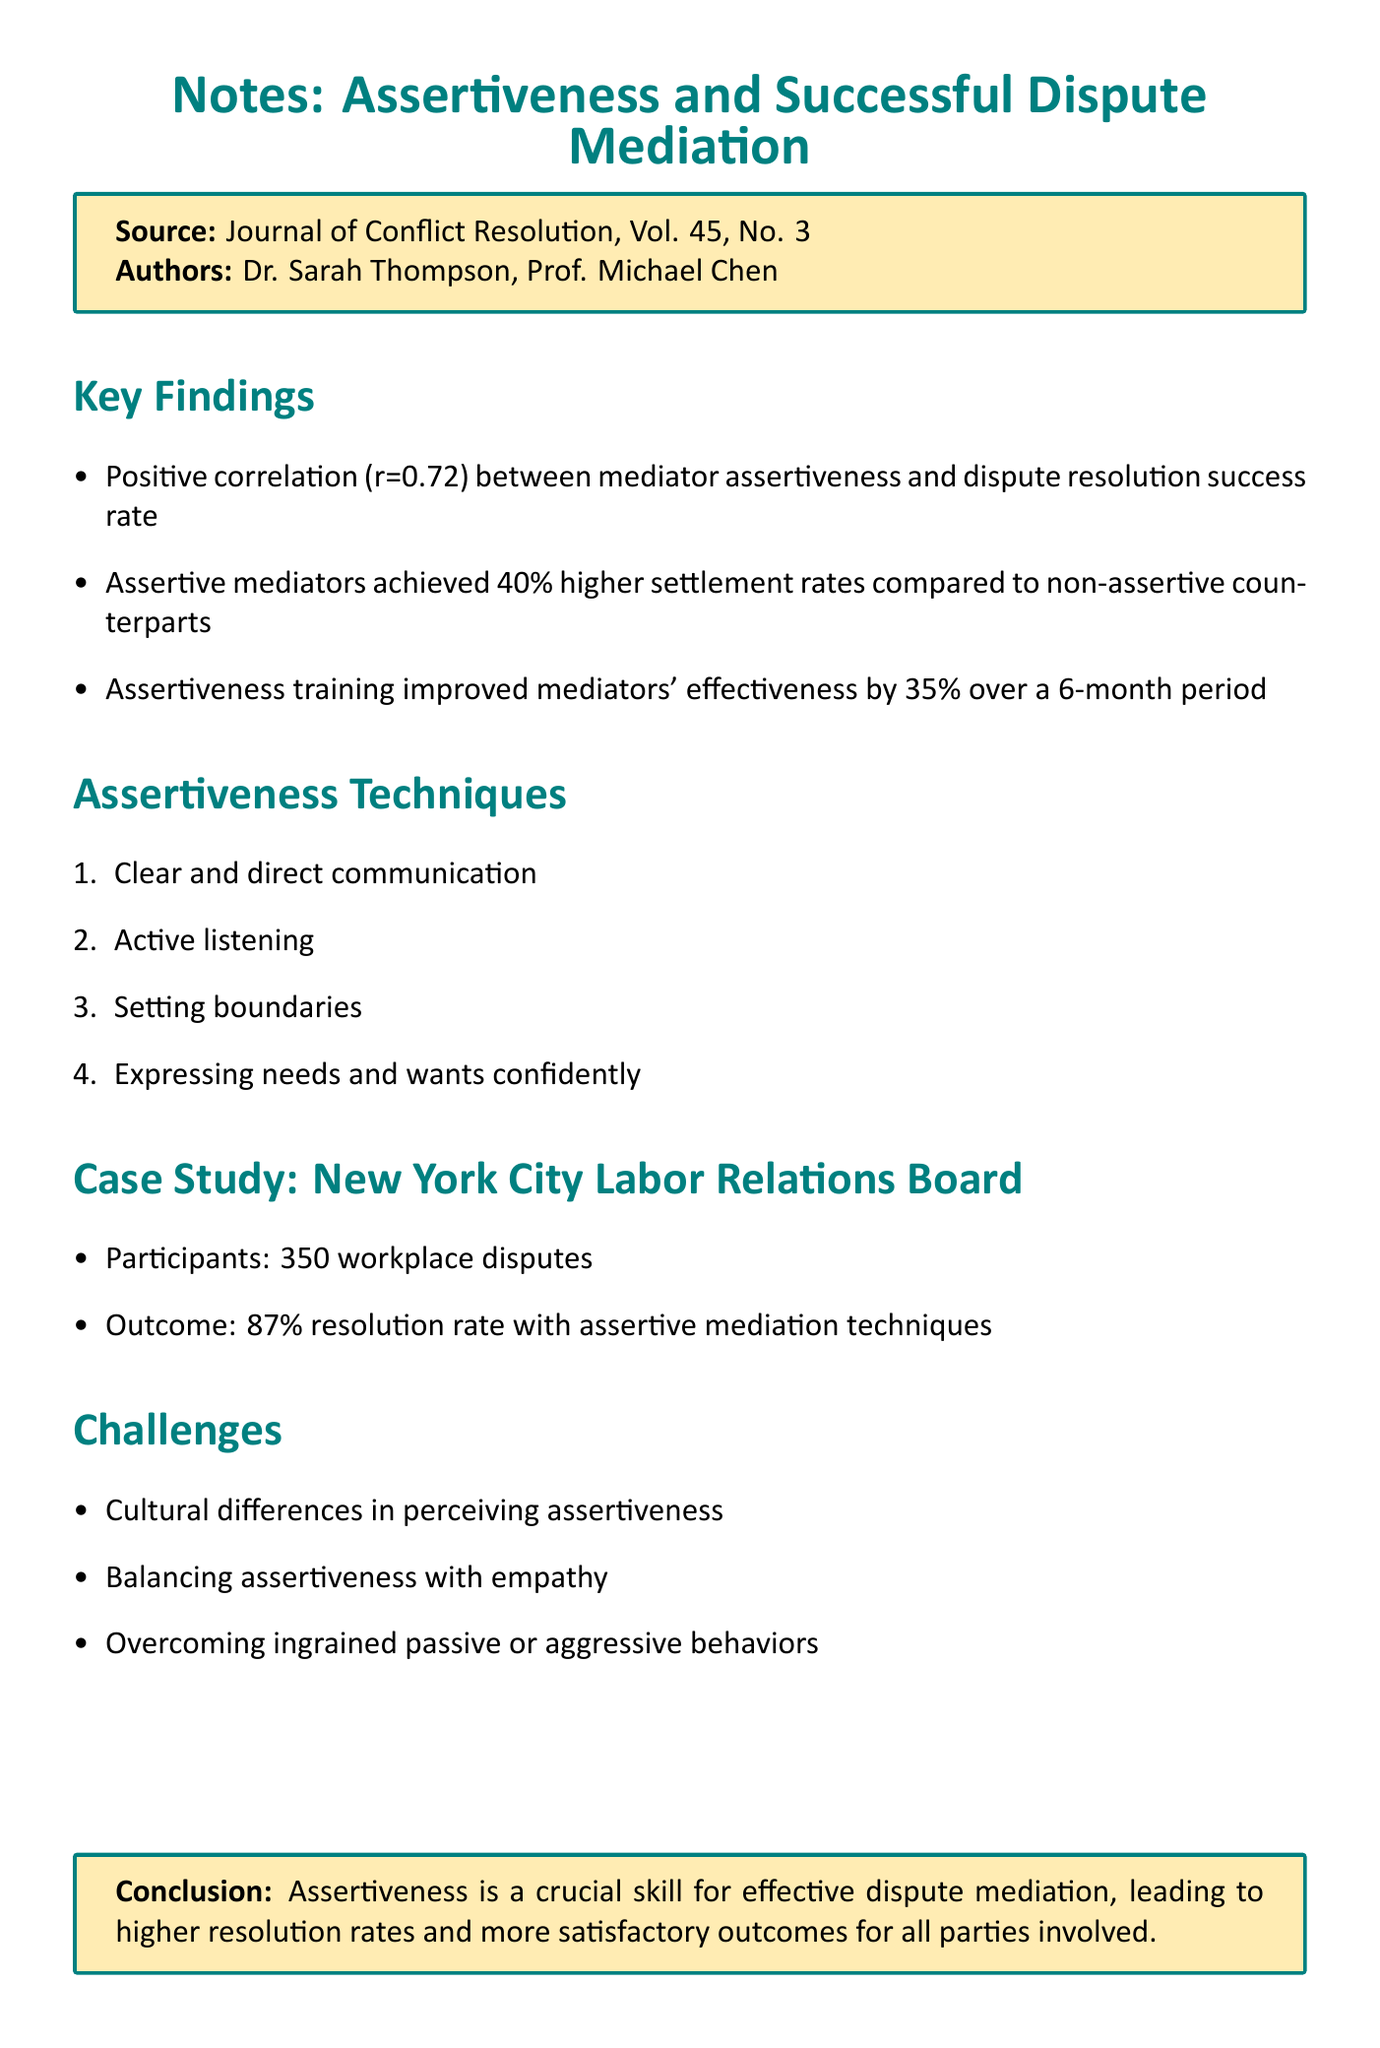What is the title of the document? The title is explicitly stated at the beginning of the document.
Answer: Notes: Assertiveness and Successful Dispute Mediation Who are the authors of the research article? The authors are listed in the source section of the document.
Answer: Dr. Sarah Thompson, Prof. Michael Chen What is the positive correlation coefficient between mediator assertiveness and dispute resolution success rate? The correlation is mentioned in the key findings section of the document.
Answer: 0.72 By how much did assertive mediators achieve higher settlement rates compared to non-assertive counterparts? This comparison is found in the key findings of the document.
Answer: 40% What percentage improvement in effectiveness was seen from assertiveness training over 6 months? The improvement percentage is noted in the key findings section of the document.
Answer: 35% What was the resolution rate achieved with assertive mediation techniques in the case study? The outcome of the case study provides this resolution rate.
Answer: 87% What is one of the challenges related to assertiveness in dispute mediation? Challenges are listed in the document; there are multiple options given.
Answer: Cultural differences in perceiving assertiveness What is a technique for assertiveness mentioned in the document? Techniques for assertiveness are outlined in a specific section.
Answer: Clear and direct communication 